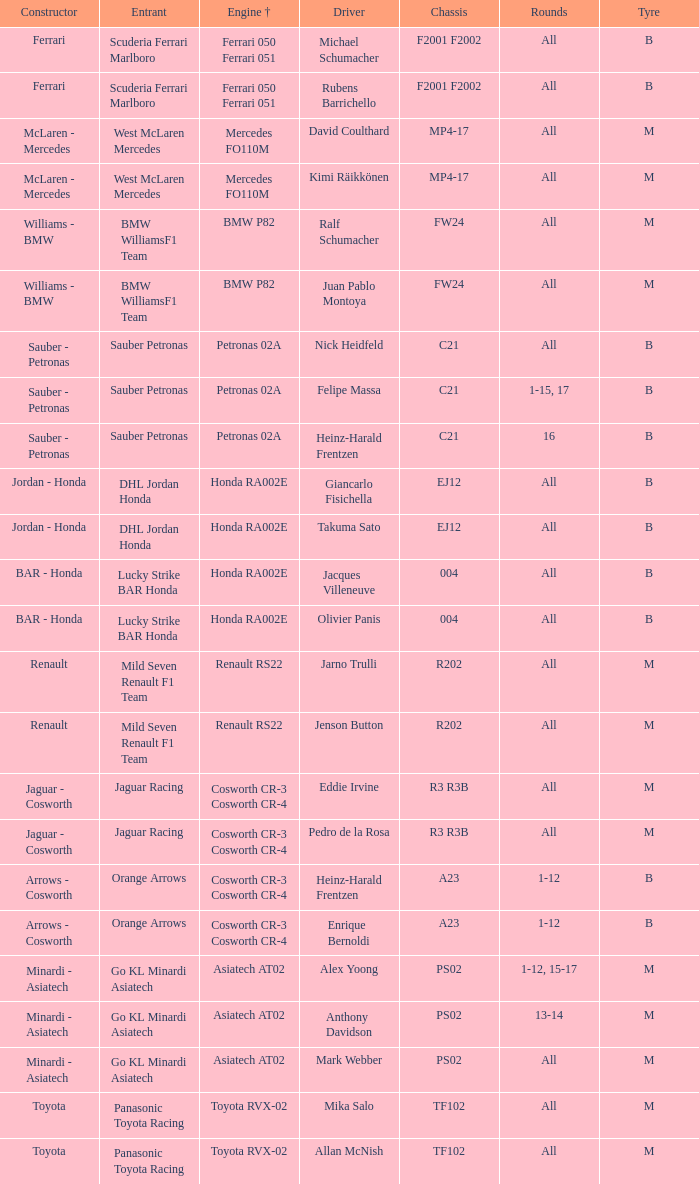What is the chassis when the tyre is b, the engine is ferrari 050 ferrari 051 and the driver is rubens barrichello? F2001 F2002. 